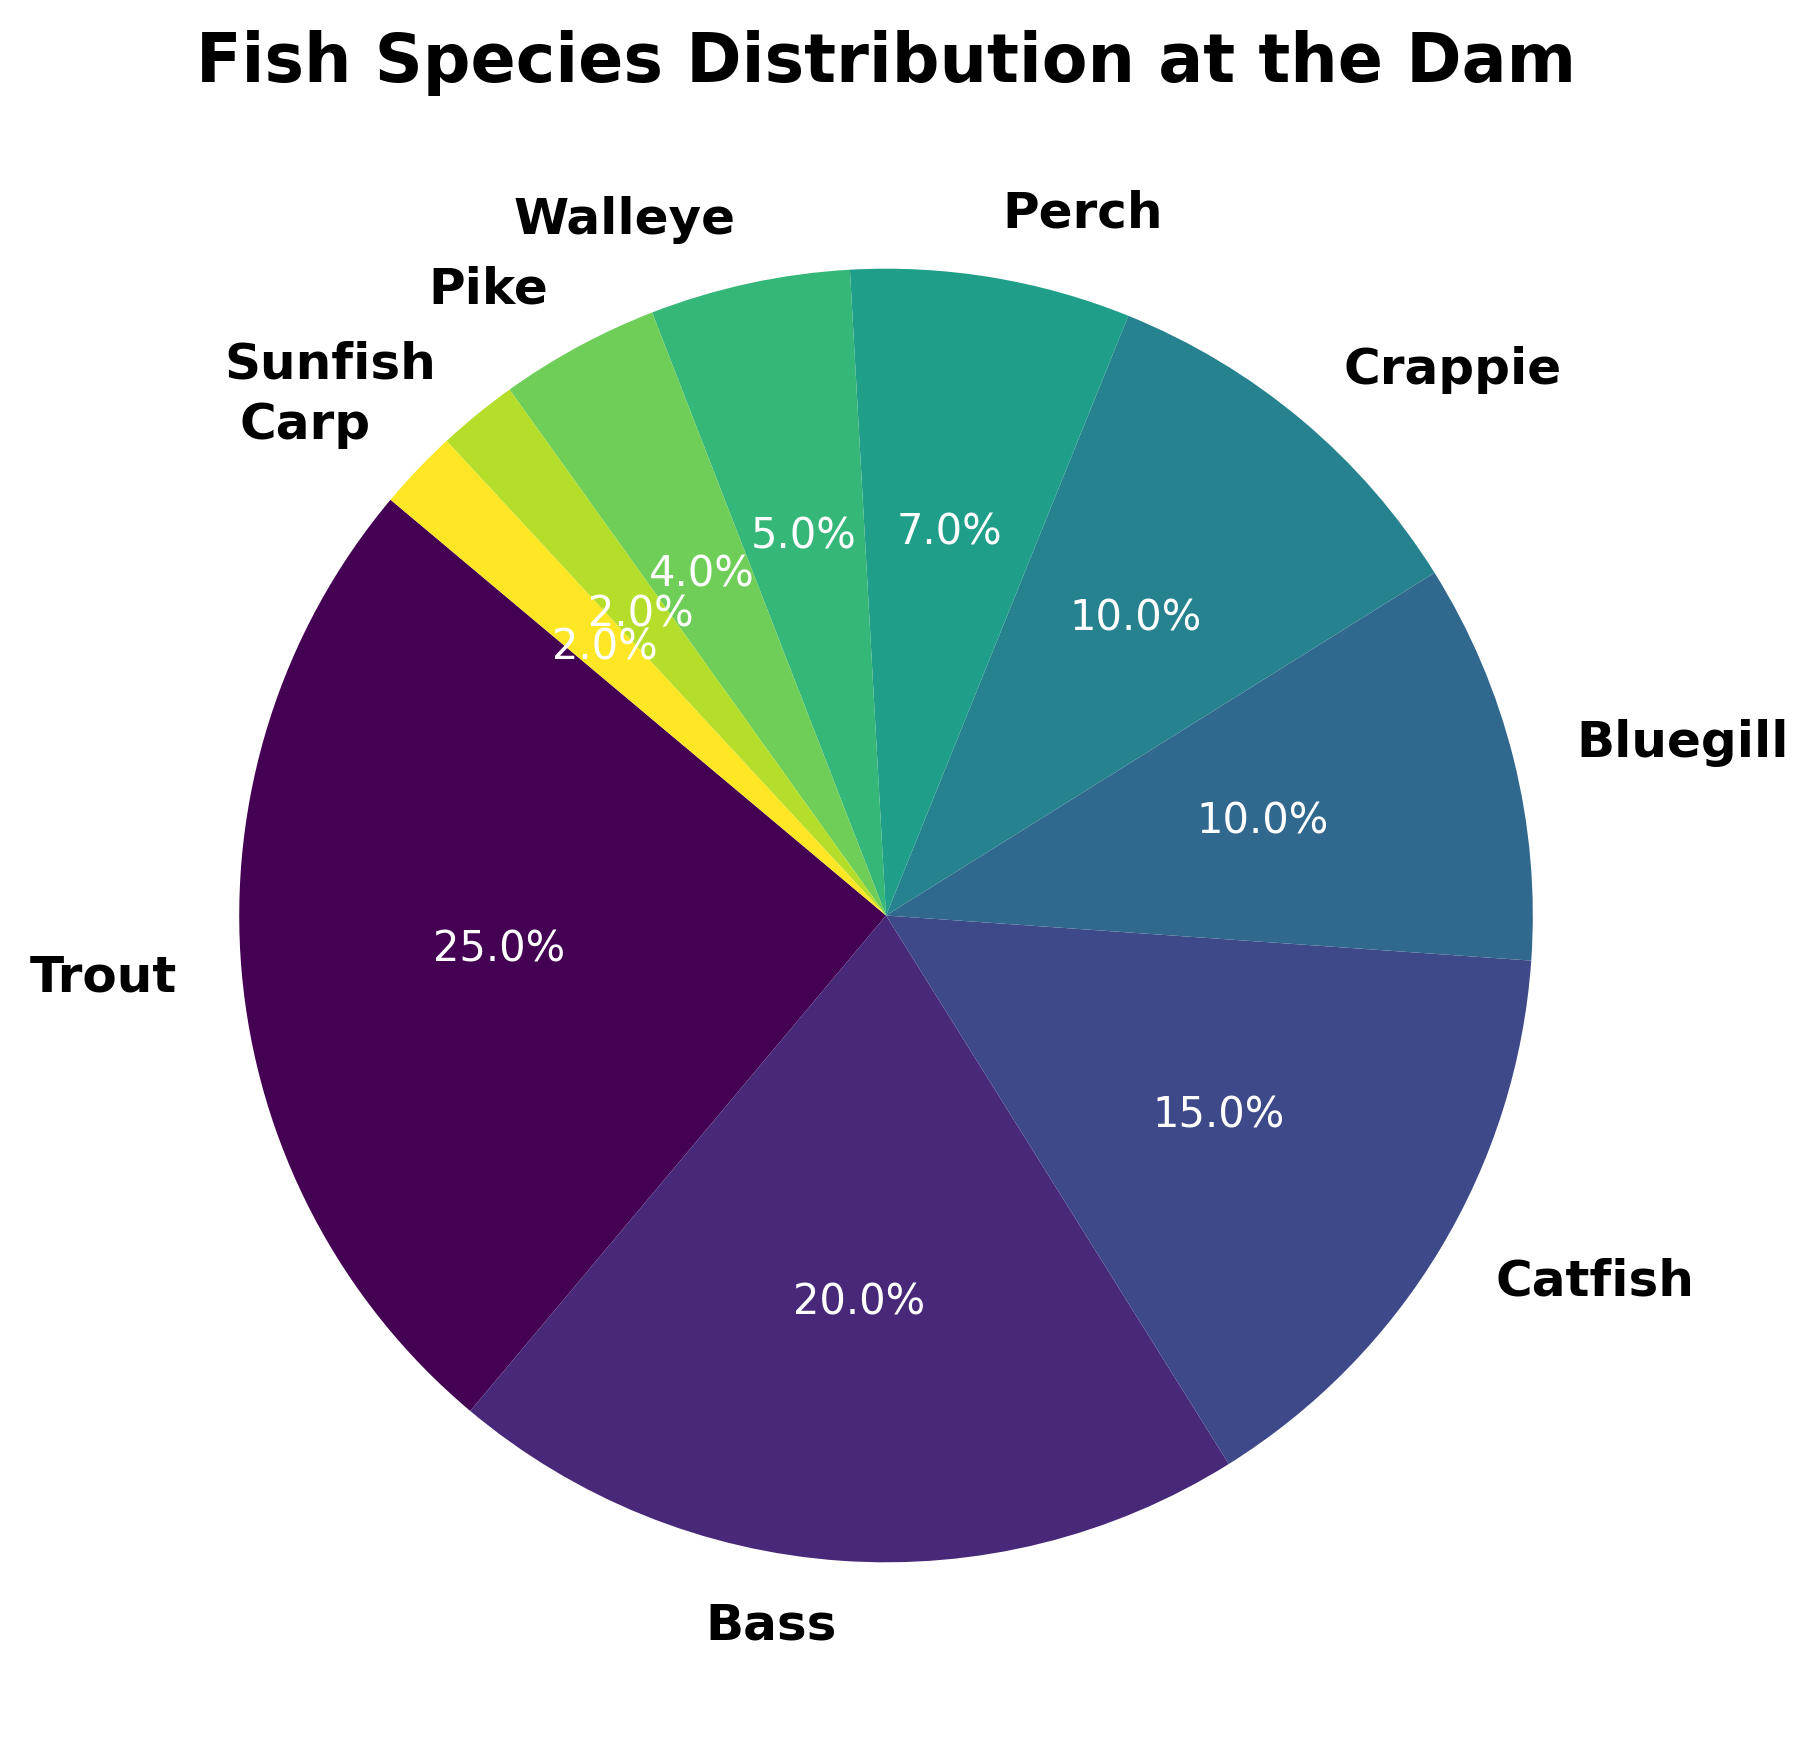What is the most common fish species at the dam? The pie chart shows the percentage distribution of different fish species. The species with the highest percentage is the most common. Trout has the largest percentage at 25%.
Answer: Trout Which fish species has the least representation at the dam? The pie chart displays the percentages of different fish species. The species with the smallest percentage is the least represented. Both Sunfish and Carp have the smallest percentage at 2% each.
Answer: Sunfish and Carp Between Bass and Catfish, which species is more prevalent? By comparing the percentages of Bass and Catfish shown on the chart, we see that Bass is 20% and Catfish is 15%. Therefore, Bass is more prevalent.
Answer: Bass How many fish species make up less than 10% of the total? We examine each fish species on the pie chart and count those with percentages less than 10%. These are Perch (7%), Walleye (5%), Pike (4%), Sunfish (2%), and Carp (2%), making a total of 5 species.
Answer: 5 What is the combined percentage of Bluegill and Crappie? To find this, we add the percentages of Bluegill and Crappie from the pie chart. Bluegill is 10% and Crappie is 10%, so the combined percentage is 10% + 10% = 20%.
Answer: 20% Is the percentage of Perch greater than that of Walleye and Pike combined? We compare the percentage of Perch (7%) with the combined percentage of Walleye (5%) and Pike (4%). The combined percentage of Walleye and Pike is 5% + 4% = 9%, which is greater than 7%.
Answer: No What is the difference in the percentage between the most and least common fish species? The most common fish species is Trout at 25%, and the least common are Sunfish and Carp at 2%. The difference is 25% - 2% = 23%.
Answer: 23% What percentage of the total fish species is made up of Trout, Bass, and Catfish combined? We sum the percentages of Trout (25%), Bass (20%), and Catfish (15%). The total is 25% + 20% + 15% = 60%.
Answer: 60% How does the percentage of Pike compare to that of Sunfish? The pie chart shows Pike at 4% and Sunfish at 2%. Pike’s percentage is greater than that of Sunfish.
Answer: Greater 